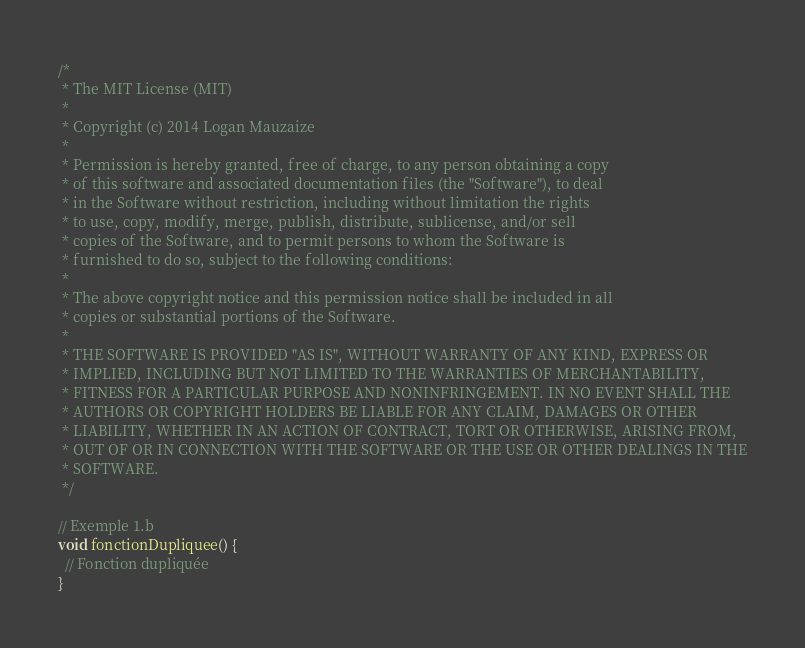Convert code to text. <code><loc_0><loc_0><loc_500><loc_500><_Ceylon_>/*
 * The MIT License (MIT)
 * 
 * Copyright (c) 2014 Logan Mauzaize
 * 
 * Permission is hereby granted, free of charge, to any person obtaining a copy
 * of this software and associated documentation files (the "Software"), to deal
 * in the Software without restriction, including without limitation the rights
 * to use, copy, modify, merge, publish, distribute, sublicense, and/or sell
 * copies of the Software, and to permit persons to whom the Software is
 * furnished to do so, subject to the following conditions:
 *
 * The above copyright notice and this permission notice shall be included in all
 * copies or substantial portions of the Software.
 *
 * THE SOFTWARE IS PROVIDED "AS IS", WITHOUT WARRANTY OF ANY KIND, EXPRESS OR
 * IMPLIED, INCLUDING BUT NOT LIMITED TO THE WARRANTIES OF MERCHANTABILITY,
 * FITNESS FOR A PARTICULAR PURPOSE AND NONINFRINGEMENT. IN NO EVENT SHALL THE
 * AUTHORS OR COPYRIGHT HOLDERS BE LIABLE FOR ANY CLAIM, DAMAGES OR OTHER
 * LIABILITY, WHETHER IN AN ACTION OF CONTRACT, TORT OR OTHERWISE, ARISING FROM,
 * OUT OF OR IN CONNECTION WITH THE SOFTWARE OR THE USE OR OTHER DEALINGS IN THE
 * SOFTWARE.
 */

// Exemple 1.b
void fonctionDupliquee() {
  // Fonction dupliquée
}
</code> 